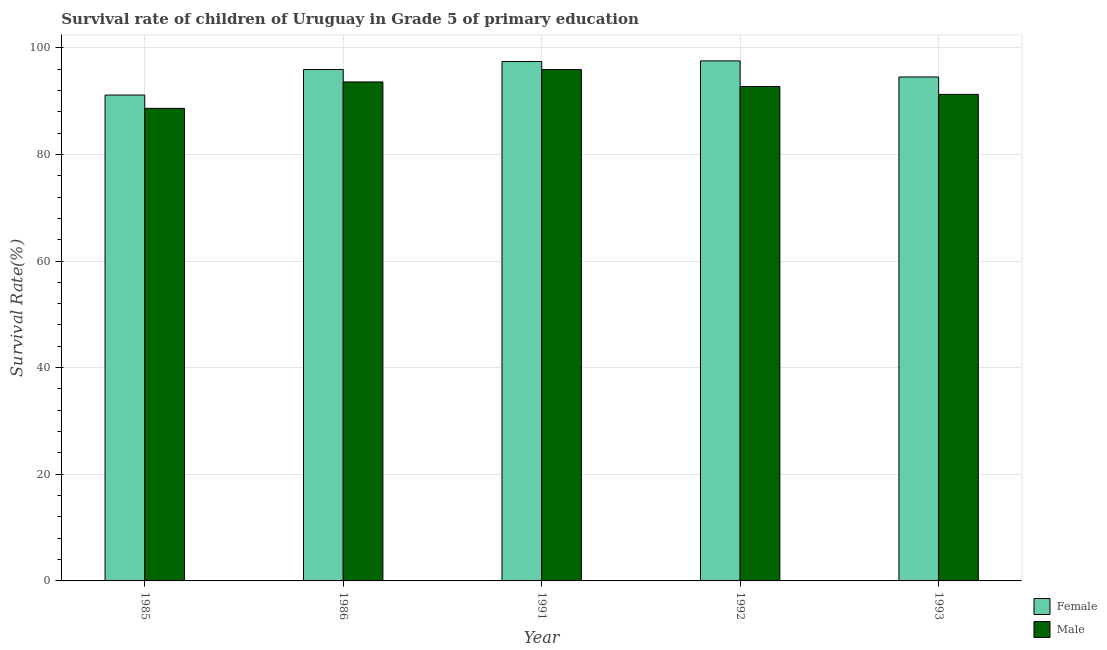How many bars are there on the 4th tick from the left?
Your answer should be very brief. 2. In how many cases, is the number of bars for a given year not equal to the number of legend labels?
Your answer should be compact. 0. What is the survival rate of female students in primary education in 1986?
Keep it short and to the point. 95.93. Across all years, what is the maximum survival rate of female students in primary education?
Provide a succinct answer. 97.54. Across all years, what is the minimum survival rate of male students in primary education?
Provide a short and direct response. 88.63. What is the total survival rate of female students in primary education in the graph?
Your answer should be compact. 476.54. What is the difference between the survival rate of female students in primary education in 1986 and that in 1991?
Your answer should be compact. -1.5. What is the difference between the survival rate of male students in primary education in 1991 and the survival rate of female students in primary education in 1993?
Your answer should be very brief. 4.65. What is the average survival rate of female students in primary education per year?
Provide a short and direct response. 95.31. What is the ratio of the survival rate of female students in primary education in 1991 to that in 1993?
Offer a very short reply. 1.03. Is the survival rate of male students in primary education in 1986 less than that in 1993?
Provide a succinct answer. No. Is the difference between the survival rate of male students in primary education in 1986 and 1991 greater than the difference between the survival rate of female students in primary education in 1986 and 1991?
Provide a succinct answer. No. What is the difference between the highest and the second highest survival rate of male students in primary education?
Keep it short and to the point. 2.32. What is the difference between the highest and the lowest survival rate of female students in primary education?
Provide a short and direct response. 6.41. What does the 2nd bar from the left in 1993 represents?
Provide a short and direct response. Male. What does the 2nd bar from the right in 1985 represents?
Provide a succinct answer. Female. How many years are there in the graph?
Your answer should be compact. 5. Are the values on the major ticks of Y-axis written in scientific E-notation?
Keep it short and to the point. No. Where does the legend appear in the graph?
Provide a short and direct response. Bottom right. What is the title of the graph?
Keep it short and to the point. Survival rate of children of Uruguay in Grade 5 of primary education. Does "Formally registered" appear as one of the legend labels in the graph?
Offer a very short reply. No. What is the label or title of the X-axis?
Provide a succinct answer. Year. What is the label or title of the Y-axis?
Keep it short and to the point. Survival Rate(%). What is the Survival Rate(%) of Female in 1985?
Your answer should be very brief. 91.13. What is the Survival Rate(%) in Male in 1985?
Give a very brief answer. 88.63. What is the Survival Rate(%) in Female in 1986?
Your answer should be very brief. 95.93. What is the Survival Rate(%) in Male in 1986?
Provide a short and direct response. 93.58. What is the Survival Rate(%) in Female in 1991?
Keep it short and to the point. 97.43. What is the Survival Rate(%) in Male in 1991?
Make the answer very short. 95.9. What is the Survival Rate(%) of Female in 1992?
Give a very brief answer. 97.54. What is the Survival Rate(%) in Male in 1992?
Offer a very short reply. 92.73. What is the Survival Rate(%) of Female in 1993?
Your answer should be compact. 94.52. What is the Survival Rate(%) of Male in 1993?
Make the answer very short. 91.25. Across all years, what is the maximum Survival Rate(%) in Female?
Your answer should be compact. 97.54. Across all years, what is the maximum Survival Rate(%) in Male?
Your answer should be compact. 95.9. Across all years, what is the minimum Survival Rate(%) in Female?
Offer a very short reply. 91.13. Across all years, what is the minimum Survival Rate(%) of Male?
Your answer should be compact. 88.63. What is the total Survival Rate(%) in Female in the graph?
Ensure brevity in your answer.  476.54. What is the total Survival Rate(%) in Male in the graph?
Offer a very short reply. 462.1. What is the difference between the Survival Rate(%) in Female in 1985 and that in 1986?
Keep it short and to the point. -4.8. What is the difference between the Survival Rate(%) of Male in 1985 and that in 1986?
Provide a succinct answer. -4.96. What is the difference between the Survival Rate(%) in Female in 1985 and that in 1991?
Your answer should be very brief. -6.3. What is the difference between the Survival Rate(%) in Male in 1985 and that in 1991?
Ensure brevity in your answer.  -7.27. What is the difference between the Survival Rate(%) of Female in 1985 and that in 1992?
Give a very brief answer. -6.41. What is the difference between the Survival Rate(%) in Male in 1985 and that in 1992?
Make the answer very short. -4.1. What is the difference between the Survival Rate(%) in Female in 1985 and that in 1993?
Give a very brief answer. -3.39. What is the difference between the Survival Rate(%) of Male in 1985 and that in 1993?
Ensure brevity in your answer.  -2.62. What is the difference between the Survival Rate(%) of Female in 1986 and that in 1991?
Offer a very short reply. -1.5. What is the difference between the Survival Rate(%) of Male in 1986 and that in 1991?
Your response must be concise. -2.32. What is the difference between the Survival Rate(%) in Female in 1986 and that in 1992?
Make the answer very short. -1.61. What is the difference between the Survival Rate(%) of Male in 1986 and that in 1992?
Make the answer very short. 0.86. What is the difference between the Survival Rate(%) in Female in 1986 and that in 1993?
Offer a very short reply. 1.41. What is the difference between the Survival Rate(%) in Male in 1986 and that in 1993?
Provide a succinct answer. 2.33. What is the difference between the Survival Rate(%) in Female in 1991 and that in 1992?
Your answer should be very brief. -0.11. What is the difference between the Survival Rate(%) of Male in 1991 and that in 1992?
Provide a succinct answer. 3.18. What is the difference between the Survival Rate(%) in Female in 1991 and that in 1993?
Your answer should be very brief. 2.91. What is the difference between the Survival Rate(%) in Male in 1991 and that in 1993?
Offer a terse response. 4.65. What is the difference between the Survival Rate(%) of Female in 1992 and that in 1993?
Keep it short and to the point. 3.02. What is the difference between the Survival Rate(%) of Male in 1992 and that in 1993?
Your response must be concise. 1.47. What is the difference between the Survival Rate(%) of Female in 1985 and the Survival Rate(%) of Male in 1986?
Provide a succinct answer. -2.46. What is the difference between the Survival Rate(%) of Female in 1985 and the Survival Rate(%) of Male in 1991?
Your answer should be very brief. -4.77. What is the difference between the Survival Rate(%) in Female in 1985 and the Survival Rate(%) in Male in 1992?
Offer a very short reply. -1.6. What is the difference between the Survival Rate(%) in Female in 1985 and the Survival Rate(%) in Male in 1993?
Your answer should be compact. -0.12. What is the difference between the Survival Rate(%) in Female in 1986 and the Survival Rate(%) in Male in 1991?
Give a very brief answer. 0.03. What is the difference between the Survival Rate(%) in Female in 1986 and the Survival Rate(%) in Male in 1992?
Offer a very short reply. 3.2. What is the difference between the Survival Rate(%) in Female in 1986 and the Survival Rate(%) in Male in 1993?
Your response must be concise. 4.67. What is the difference between the Survival Rate(%) in Female in 1991 and the Survival Rate(%) in Male in 1992?
Offer a very short reply. 4.7. What is the difference between the Survival Rate(%) of Female in 1991 and the Survival Rate(%) of Male in 1993?
Provide a short and direct response. 6.17. What is the difference between the Survival Rate(%) in Female in 1992 and the Survival Rate(%) in Male in 1993?
Keep it short and to the point. 6.28. What is the average Survival Rate(%) in Female per year?
Offer a terse response. 95.31. What is the average Survival Rate(%) in Male per year?
Your answer should be very brief. 92.42. In the year 1985, what is the difference between the Survival Rate(%) in Female and Survival Rate(%) in Male?
Keep it short and to the point. 2.5. In the year 1986, what is the difference between the Survival Rate(%) in Female and Survival Rate(%) in Male?
Provide a succinct answer. 2.34. In the year 1991, what is the difference between the Survival Rate(%) in Female and Survival Rate(%) in Male?
Provide a succinct answer. 1.52. In the year 1992, what is the difference between the Survival Rate(%) of Female and Survival Rate(%) of Male?
Offer a terse response. 4.81. In the year 1993, what is the difference between the Survival Rate(%) of Female and Survival Rate(%) of Male?
Ensure brevity in your answer.  3.27. What is the ratio of the Survival Rate(%) in Female in 1985 to that in 1986?
Provide a succinct answer. 0.95. What is the ratio of the Survival Rate(%) in Male in 1985 to that in 1986?
Your response must be concise. 0.95. What is the ratio of the Survival Rate(%) in Female in 1985 to that in 1991?
Your answer should be compact. 0.94. What is the ratio of the Survival Rate(%) of Male in 1985 to that in 1991?
Provide a succinct answer. 0.92. What is the ratio of the Survival Rate(%) of Female in 1985 to that in 1992?
Your answer should be very brief. 0.93. What is the ratio of the Survival Rate(%) in Male in 1985 to that in 1992?
Give a very brief answer. 0.96. What is the ratio of the Survival Rate(%) in Female in 1985 to that in 1993?
Provide a succinct answer. 0.96. What is the ratio of the Survival Rate(%) in Male in 1985 to that in 1993?
Make the answer very short. 0.97. What is the ratio of the Survival Rate(%) of Female in 1986 to that in 1991?
Offer a very short reply. 0.98. What is the ratio of the Survival Rate(%) in Male in 1986 to that in 1991?
Ensure brevity in your answer.  0.98. What is the ratio of the Survival Rate(%) of Female in 1986 to that in 1992?
Offer a very short reply. 0.98. What is the ratio of the Survival Rate(%) in Male in 1986 to that in 1992?
Make the answer very short. 1.01. What is the ratio of the Survival Rate(%) in Female in 1986 to that in 1993?
Make the answer very short. 1.01. What is the ratio of the Survival Rate(%) of Male in 1986 to that in 1993?
Provide a succinct answer. 1.03. What is the ratio of the Survival Rate(%) in Female in 1991 to that in 1992?
Keep it short and to the point. 1. What is the ratio of the Survival Rate(%) of Male in 1991 to that in 1992?
Offer a very short reply. 1.03. What is the ratio of the Survival Rate(%) of Female in 1991 to that in 1993?
Provide a short and direct response. 1.03. What is the ratio of the Survival Rate(%) of Male in 1991 to that in 1993?
Give a very brief answer. 1.05. What is the ratio of the Survival Rate(%) of Female in 1992 to that in 1993?
Offer a terse response. 1.03. What is the ratio of the Survival Rate(%) of Male in 1992 to that in 1993?
Provide a short and direct response. 1.02. What is the difference between the highest and the second highest Survival Rate(%) of Female?
Provide a succinct answer. 0.11. What is the difference between the highest and the second highest Survival Rate(%) of Male?
Make the answer very short. 2.32. What is the difference between the highest and the lowest Survival Rate(%) of Female?
Make the answer very short. 6.41. What is the difference between the highest and the lowest Survival Rate(%) of Male?
Make the answer very short. 7.27. 